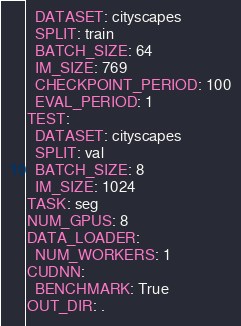<code> <loc_0><loc_0><loc_500><loc_500><_YAML_>  DATASET: cityscapes
  SPLIT: train
  BATCH_SIZE: 64
  IM_SIZE: 769
  CHECKPOINT_PERIOD: 100
  EVAL_PERIOD: 1
TEST:
  DATASET: cityscapes
  SPLIT: val
  BATCH_SIZE: 8
  IM_SIZE: 1024
TASK: seg
NUM_GPUS: 8
DATA_LOADER:
  NUM_WORKERS: 1
CUDNN:
  BENCHMARK: True
OUT_DIR: .
</code> 